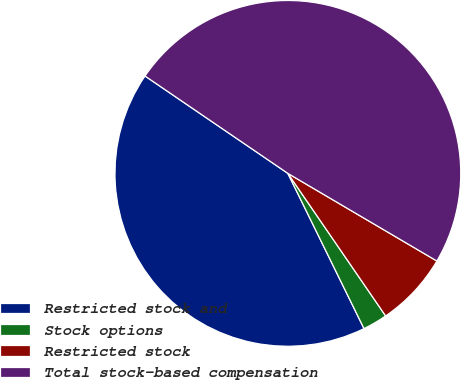Convert chart to OTSL. <chart><loc_0><loc_0><loc_500><loc_500><pie_chart><fcel>Restricted stock and<fcel>Stock options<fcel>Restricted stock<fcel>Total stock-based compensation<nl><fcel>41.78%<fcel>2.31%<fcel>6.97%<fcel>48.94%<nl></chart> 